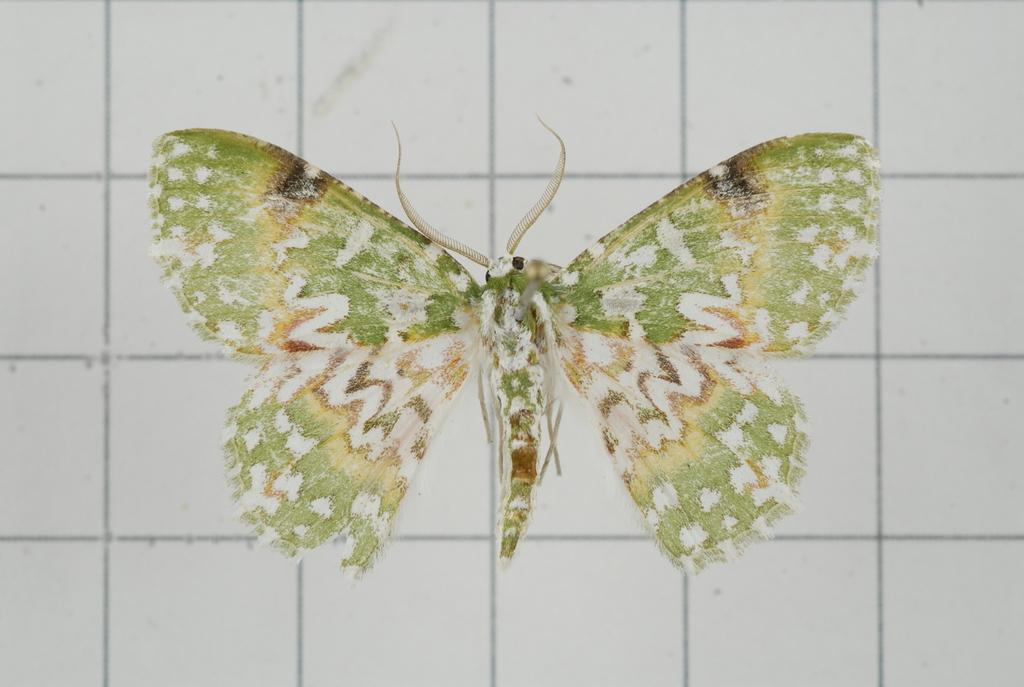What is present on the wall in the image? There is a wall painting on the wall in the image. Can you describe the wall painting? Unfortunately, the description of the wall painting is not provided in the facts. However, we can confirm that there is a wall painting on the wall. What types of toys are scattered around the wall painting in the image? There is no mention of toys in the image, so we cannot answer this question. 